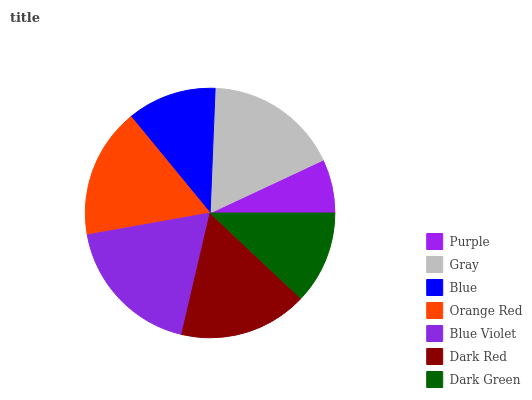Is Purple the minimum?
Answer yes or no. Yes. Is Blue Violet the maximum?
Answer yes or no. Yes. Is Gray the minimum?
Answer yes or no. No. Is Gray the maximum?
Answer yes or no. No. Is Gray greater than Purple?
Answer yes or no. Yes. Is Purple less than Gray?
Answer yes or no. Yes. Is Purple greater than Gray?
Answer yes or no. No. Is Gray less than Purple?
Answer yes or no. No. Is Dark Red the high median?
Answer yes or no. Yes. Is Dark Red the low median?
Answer yes or no. Yes. Is Purple the high median?
Answer yes or no. No. Is Purple the low median?
Answer yes or no. No. 